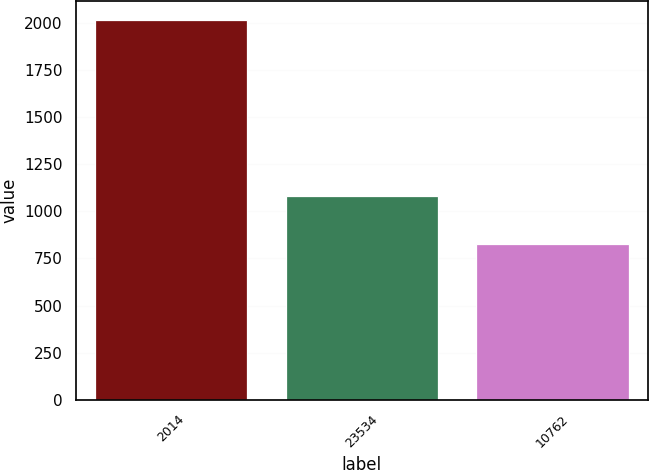Convert chart. <chart><loc_0><loc_0><loc_500><loc_500><bar_chart><fcel>2014<fcel>23534<fcel>10762<nl><fcel>2014<fcel>1081.8<fcel>824.3<nl></chart> 